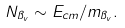Convert formula to latex. <formula><loc_0><loc_0><loc_500><loc_500>N _ { \pi _ { v } } \sim E _ { c m } / m _ { \pi _ { v } } .</formula> 